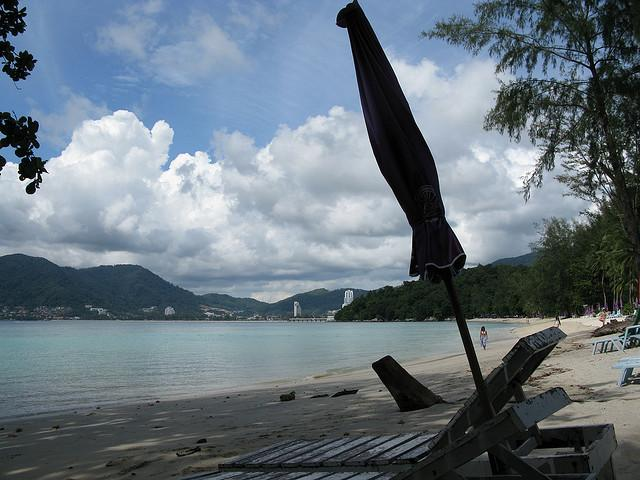What might this umbrella normally be used for? Please explain your reasoning. sun protection. This is on a beach so it is for shade 